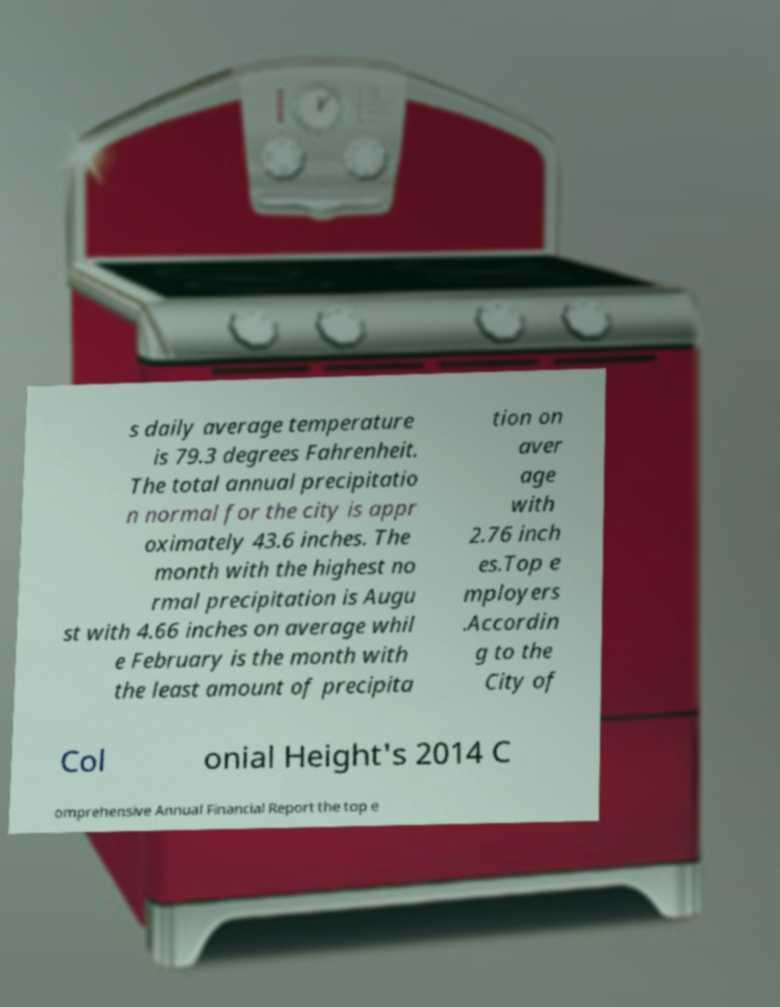Can you accurately transcribe the text from the provided image for me? s daily average temperature is 79.3 degrees Fahrenheit. The total annual precipitatio n normal for the city is appr oximately 43.6 inches. The month with the highest no rmal precipitation is Augu st with 4.66 inches on average whil e February is the month with the least amount of precipita tion on aver age with 2.76 inch es.Top e mployers .Accordin g to the City of Col onial Height's 2014 C omprehensive Annual Financial Report the top e 